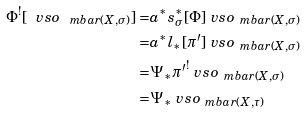Convert formula to latex. <formula><loc_0><loc_0><loc_500><loc_500>\Phi ^ { ! } [ \ v s o _ { \ m b a r ( X , \sigma ) } ] = & a ^ { * } s _ { \sigma } ^ { * } [ \Phi ] \ v s o _ { \ m b a r ( X , \sigma ) } \\ = & a ^ { * } l _ { * } [ \pi ^ { \prime } ] \ v s o _ { \ m b a r ( X , \sigma ) } \\ = & \Psi _ { * } { \pi ^ { \prime } } ^ { ! } \ v s o _ { \ m b a r ( X , \sigma ) } \\ = & \Psi _ { * } \ v s o _ { \ m b a r ( X , \tau ) }</formula> 